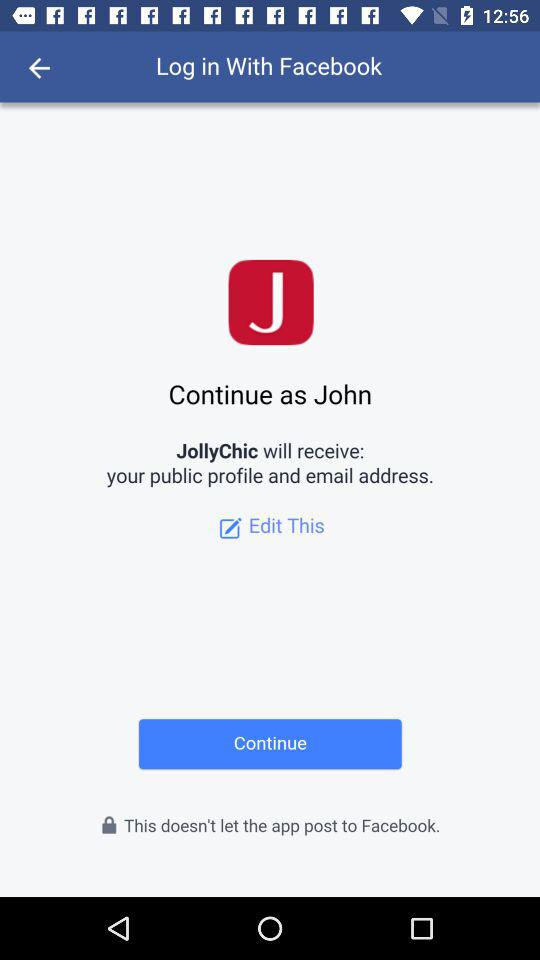What application is used for login? The application that is used for login is "Facebook". 